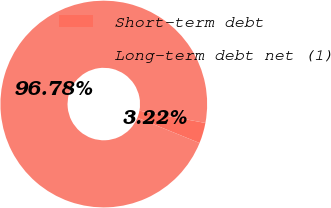<chart> <loc_0><loc_0><loc_500><loc_500><pie_chart><fcel>Short-term debt<fcel>Long-term debt net (1)<nl><fcel>3.22%<fcel>96.78%<nl></chart> 